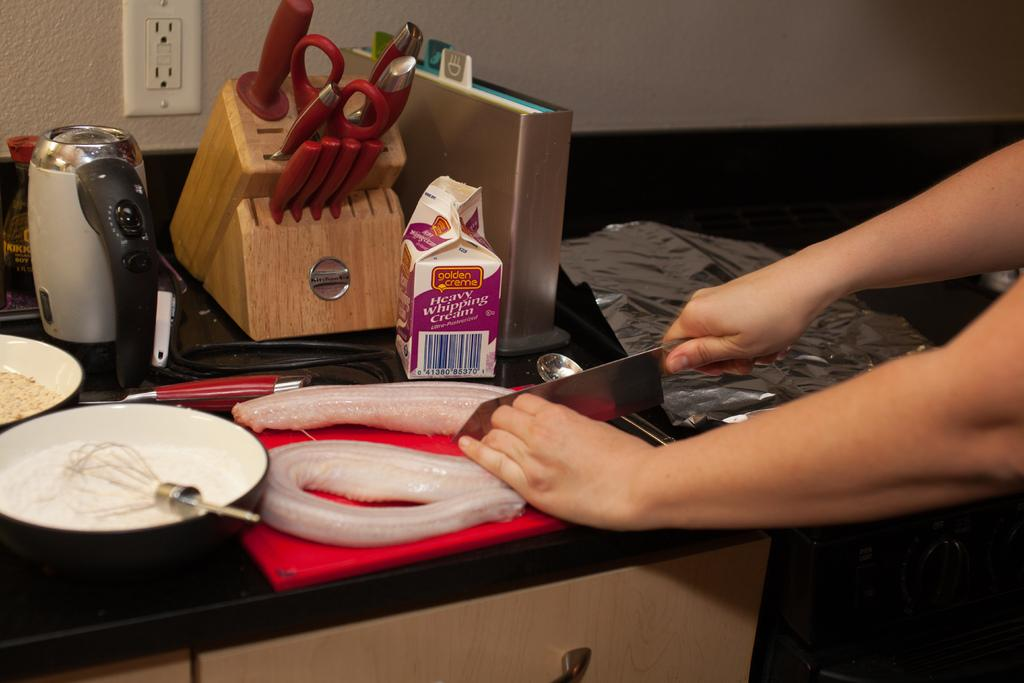Provide a one-sentence caption for the provided image. A person cutting food next to a carton of Heavy Whipping Cream on a cutting board in a kitchen. 